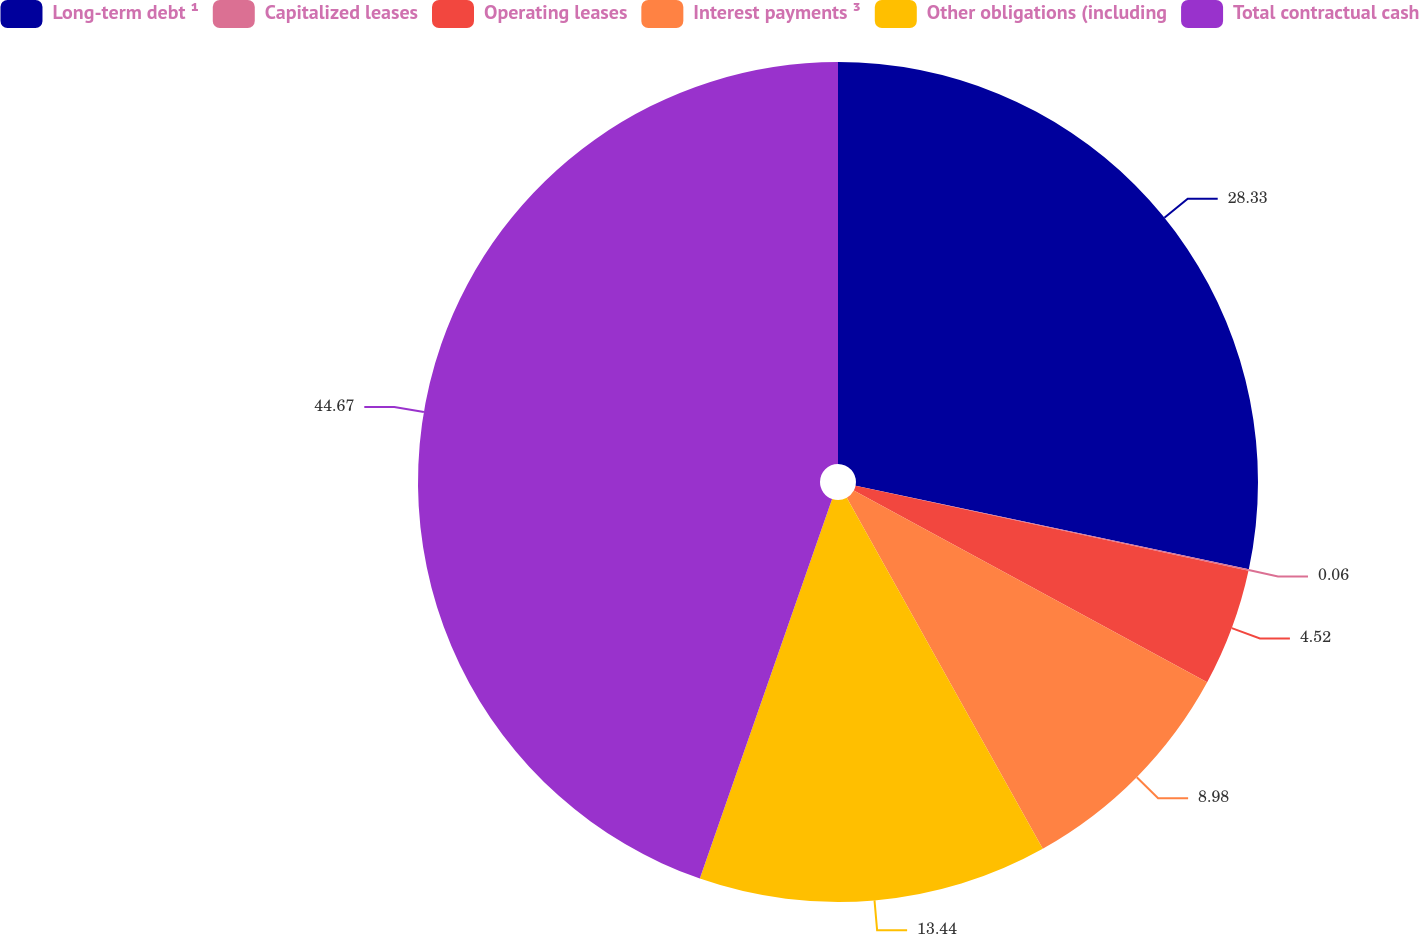<chart> <loc_0><loc_0><loc_500><loc_500><pie_chart><fcel>Long-term debt ¹<fcel>Capitalized leases<fcel>Operating leases<fcel>Interest payments ³<fcel>Other obligations (including<fcel>Total contractual cash<nl><fcel>28.33%<fcel>0.06%<fcel>4.52%<fcel>8.98%<fcel>13.44%<fcel>44.66%<nl></chart> 